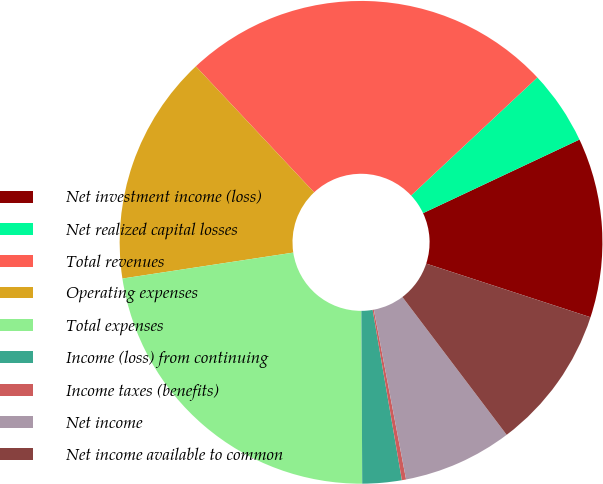Convert chart. <chart><loc_0><loc_0><loc_500><loc_500><pie_chart><fcel>Net investment income (loss)<fcel>Net realized capital losses<fcel>Total revenues<fcel>Operating expenses<fcel>Total expenses<fcel>Income (loss) from continuing<fcel>Income taxes (benefits)<fcel>Net income<fcel>Net income available to common<nl><fcel>12.02%<fcel>4.97%<fcel>25.03%<fcel>15.4%<fcel>22.68%<fcel>2.63%<fcel>0.28%<fcel>7.32%<fcel>9.67%<nl></chart> 